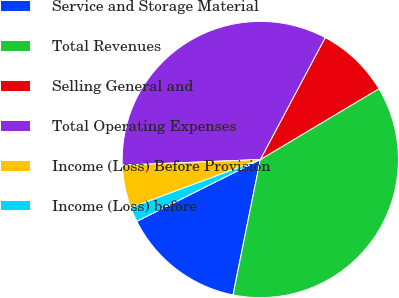<chart> <loc_0><loc_0><loc_500><loc_500><pie_chart><fcel>Service and Storage Material<fcel>Total Revenues<fcel>Selling General and<fcel>Total Operating Expenses<fcel>Income (Loss) Before Provision<fcel>Income (Loss) before<nl><fcel>14.45%<fcel>36.73%<fcel>8.65%<fcel>33.44%<fcel>5.01%<fcel>1.72%<nl></chart> 